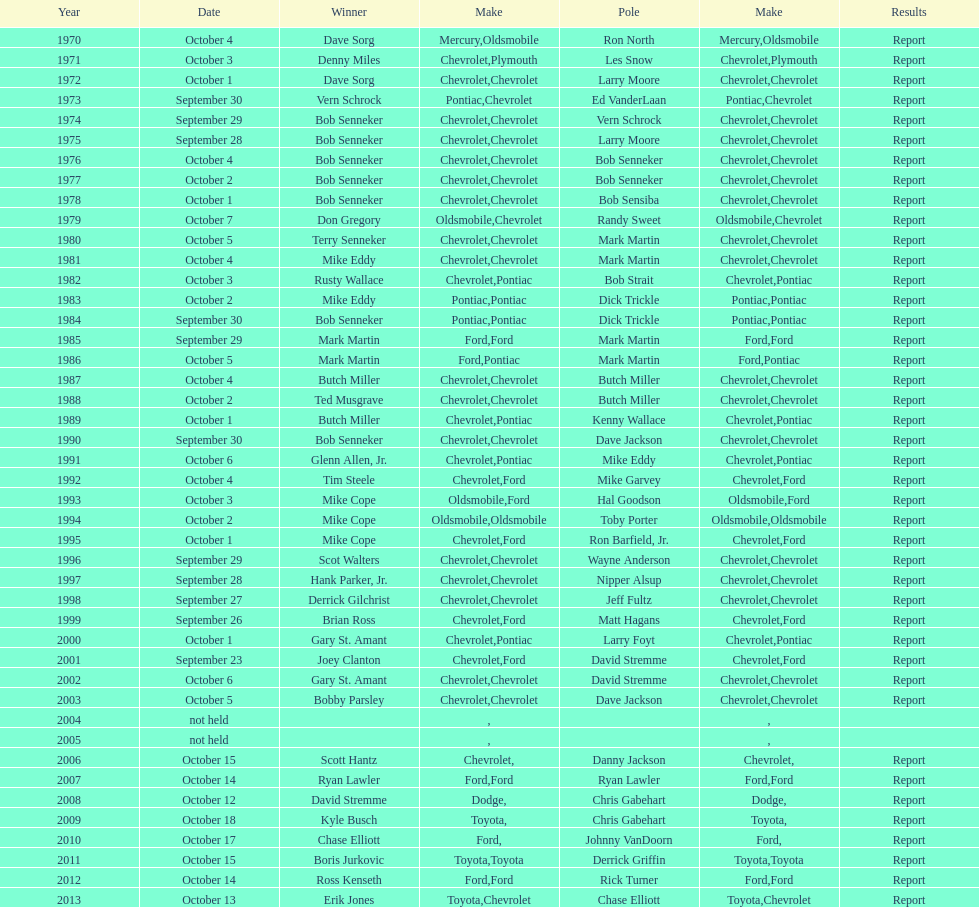What is the count of consecutive triumphs that bob senneker had? 5. 